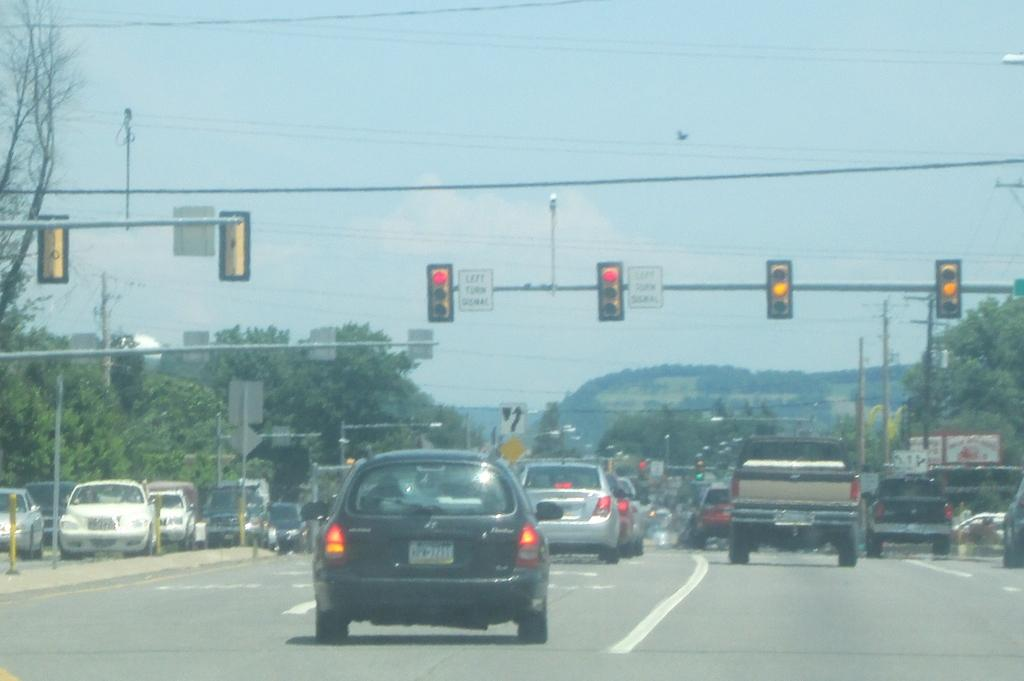What is the main feature of the image? There is a road in the image. What can be seen on the road? There are vehicles on the road. What helps regulate traffic on the road? There are traffic signal lights on poles. What type of natural elements are present around the road? There are many trees around the road. Where is the beggar standing in the image? There is no beggar present in the image. What event is taking place at the edge of the road in the image? There is no event or activity happening at the edge of the road in the image. 